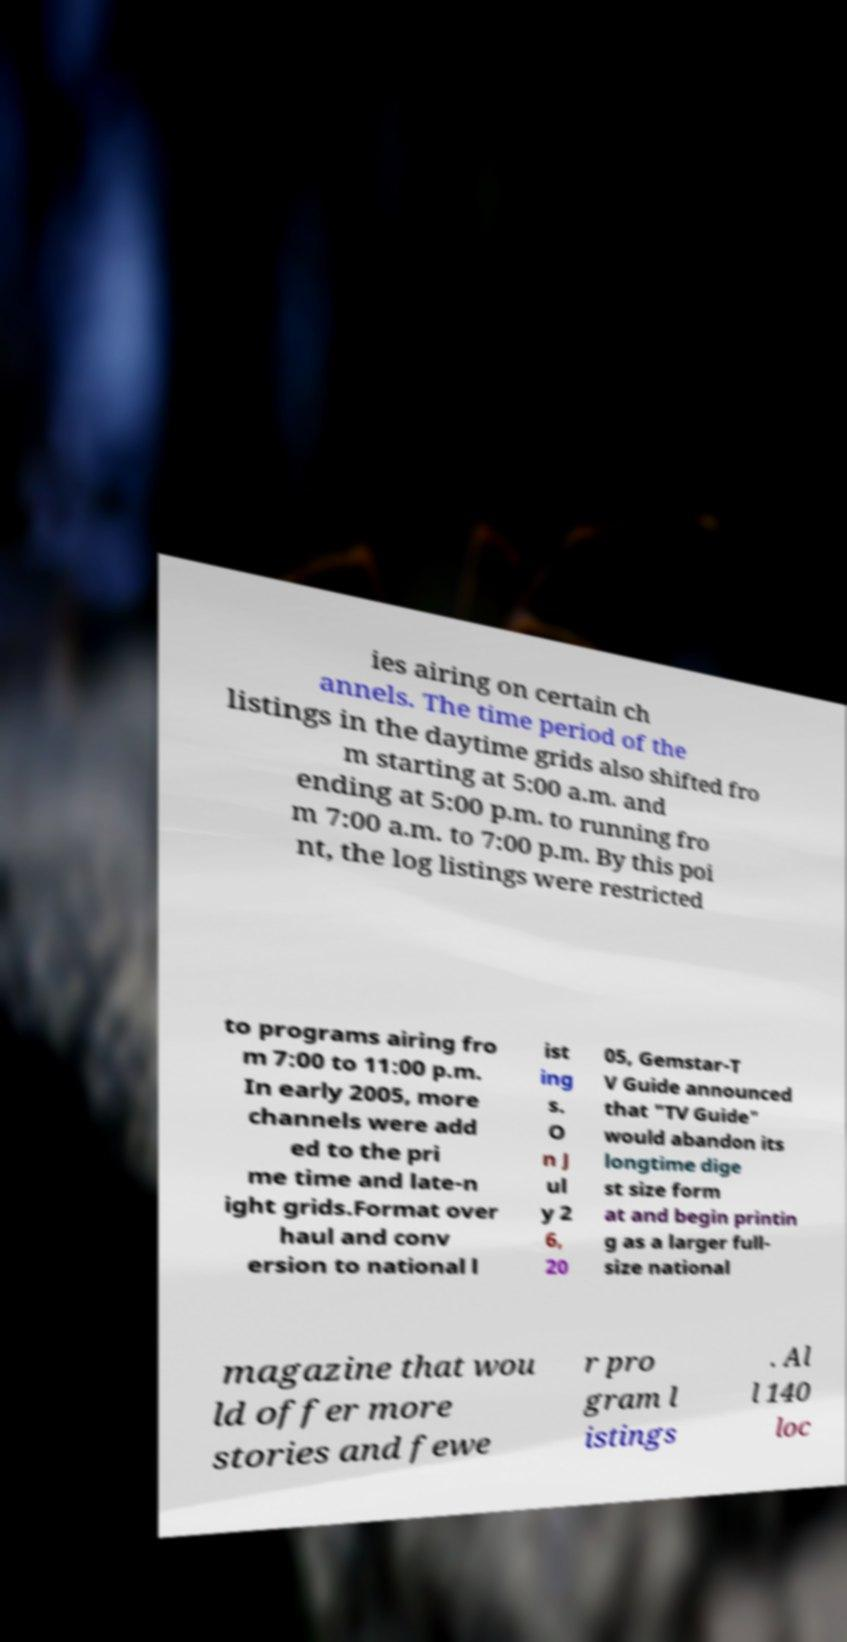I need the written content from this picture converted into text. Can you do that? ies airing on certain ch annels. The time period of the listings in the daytime grids also shifted fro m starting at 5:00 a.m. and ending at 5:00 p.m. to running fro m 7:00 a.m. to 7:00 p.m. By this poi nt, the log listings were restricted to programs airing fro m 7:00 to 11:00 p.m. In early 2005, more channels were add ed to the pri me time and late-n ight grids.Format over haul and conv ersion to national l ist ing s. O n J ul y 2 6, 20 05, Gemstar-T V Guide announced that "TV Guide" would abandon its longtime dige st size form at and begin printin g as a larger full- size national magazine that wou ld offer more stories and fewe r pro gram l istings . Al l 140 loc 